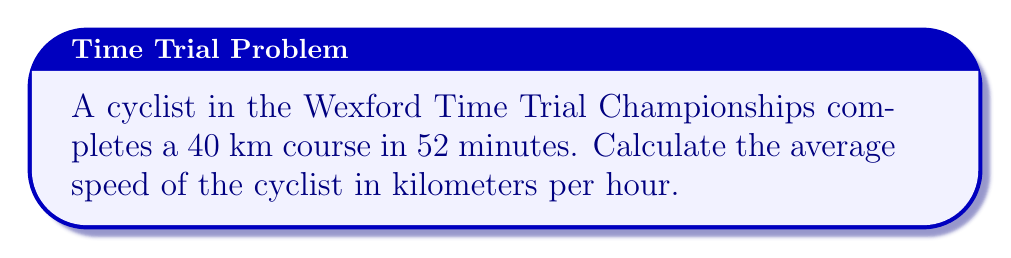Can you solve this math problem? To calculate the average speed, we need to use the formula:

$$ \text{Average Speed} = \frac{\text{Distance}}{\text{Time}} $$

Let's break it down step-by-step:

1. Given information:
   - Distance: 40 km
   - Time: 52 minutes

2. Convert time to hours:
   $$ 52 \text{ minutes} = \frac{52}{60} \text{ hours} = 0.8667 \text{ hours} $$

3. Apply the average speed formula:
   $$ \text{Average Speed} = \frac{40 \text{ km}}{0.8667 \text{ hours}} $$

4. Calculate the result:
   $$ \text{Average Speed} = 46.15 \text{ km/h} $$

5. Round to two decimal places:
   $$ \text{Average Speed} \approx 46.15 \text{ km/h} $$
Answer: 46.15 km/h 